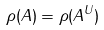<formula> <loc_0><loc_0><loc_500><loc_500>\rho ( { A } ) = \rho ( { A } ^ { U } )</formula> 